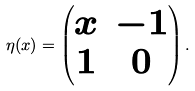<formula> <loc_0><loc_0><loc_500><loc_500>\eta ( x ) = \begin{pmatrix} x & - 1 \\ 1 & 0 \end{pmatrix} .</formula> 